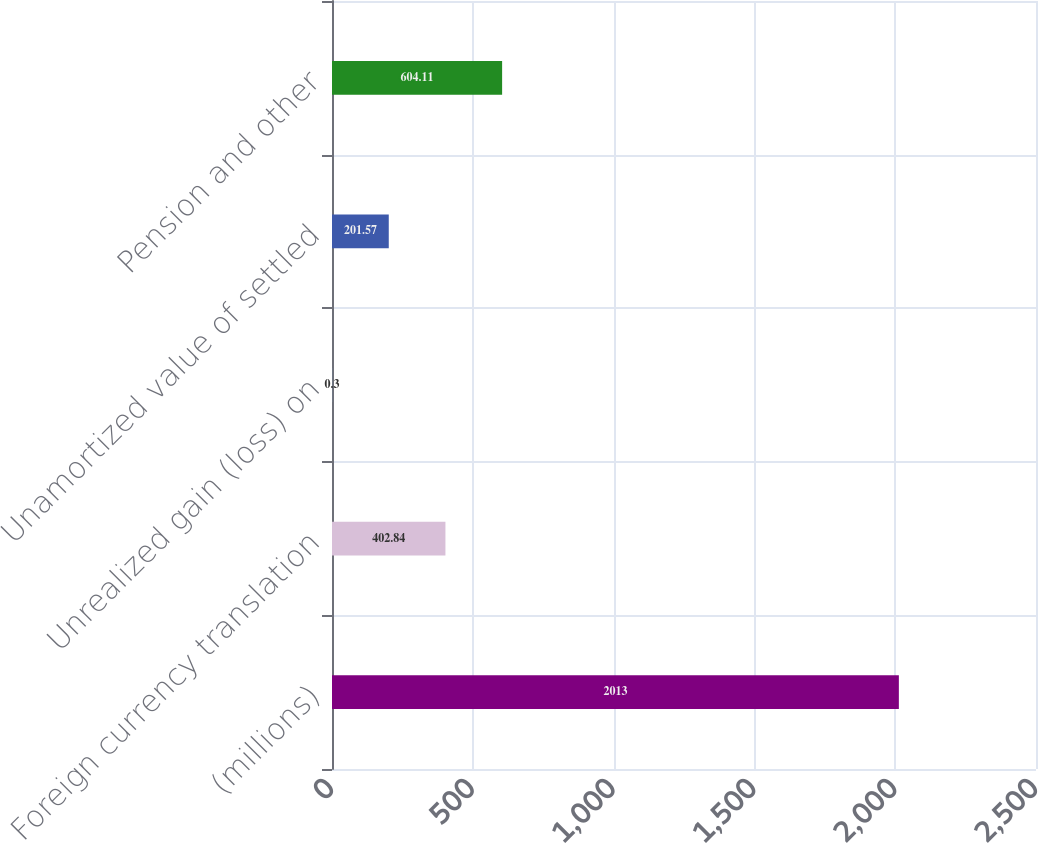<chart> <loc_0><loc_0><loc_500><loc_500><bar_chart><fcel>(millions)<fcel>Foreign currency translation<fcel>Unrealized gain (loss) on<fcel>Unamortized value of settled<fcel>Pension and other<nl><fcel>2013<fcel>402.84<fcel>0.3<fcel>201.57<fcel>604.11<nl></chart> 